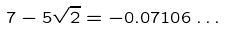<formula> <loc_0><loc_0><loc_500><loc_500>7 - 5 \sqrt { 2 } = - 0 . 0 7 1 0 6 \dots</formula> 